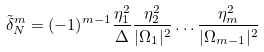Convert formula to latex. <formula><loc_0><loc_0><loc_500><loc_500>\tilde { \delta } ^ { m } _ { N } = ( - 1 ) ^ { m - 1 } \frac { \eta _ { 1 } ^ { 2 } } { \Delta } \frac { \eta _ { 2 } ^ { 2 } } { | \Omega _ { 1 } | ^ { 2 } } \dots \frac { \eta _ { m } ^ { 2 } } { | \Omega _ { m - 1 } | ^ { 2 } }</formula> 